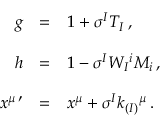<formula> <loc_0><loc_0><loc_500><loc_500>\begin{array} { r c l } { g } & { = } & { { 1 + \sigma ^ { I } T _ { I } \, , } } \\ { h } & { = } & { { 1 - \sigma ^ { I } W _ { I ^ { i } M _ { i } \, , } } \\ { { x ^ { \mu \, \prime } } } & { = } & { { x ^ { \mu } + \sigma ^ { I } k _ { ( I ) ^ { \mu } \, . } } \end{array}</formula> 